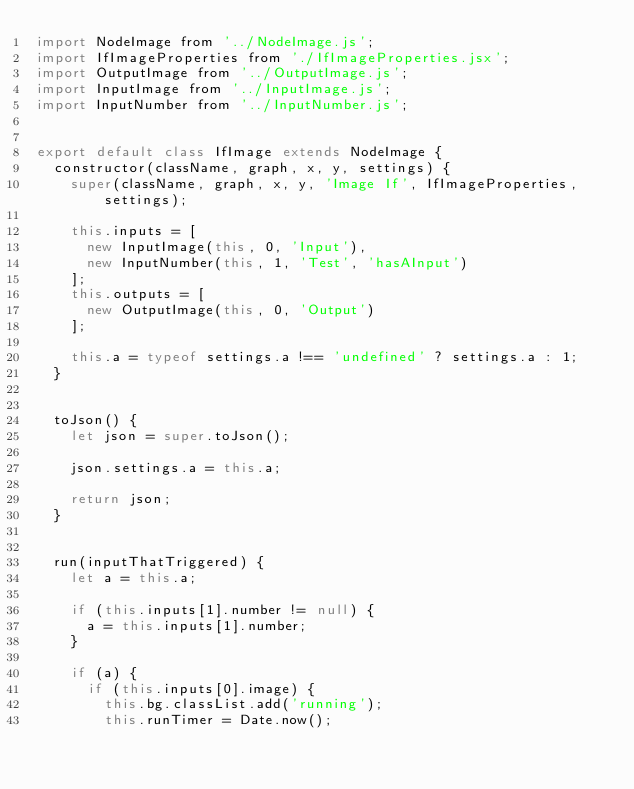Convert code to text. <code><loc_0><loc_0><loc_500><loc_500><_JavaScript_>import NodeImage from '../NodeImage.js';
import IfImageProperties from './IfImageProperties.jsx';
import OutputImage from '../OutputImage.js';
import InputImage from '../InputImage.js';
import InputNumber from '../InputNumber.js';


export default class IfImage extends NodeImage {
  constructor(className, graph, x, y, settings) {
    super(className, graph, x, y, 'Image If', IfImageProperties, settings);

    this.inputs = [
      new InputImage(this, 0, 'Input'),
      new InputNumber(this, 1, 'Test', 'hasAInput')
    ];
    this.outputs = [
      new OutputImage(this, 0, 'Output')
    ];

    this.a = typeof settings.a !== 'undefined' ? settings.a : 1;
  }


  toJson() {
    let json = super.toJson();

    json.settings.a = this.a;

    return json;
  }


  run(inputThatTriggered) {
    let a = this.a;

    if (this.inputs[1].number != null) {
      a = this.inputs[1].number;
    }

    if (a) {
      if (this.inputs[0].image) {
        this.bg.classList.add('running');
        this.runTimer = Date.now();
</code> 